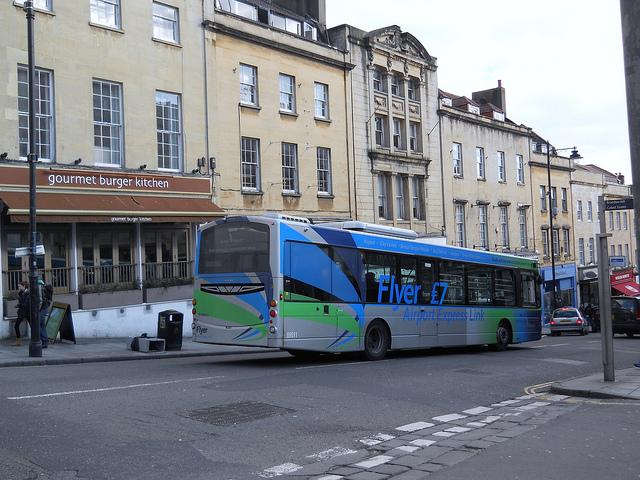What is the bus stopped outside of?

Choices:
A) gas station
B) restaurant
C) dentist
D) library restaurant 